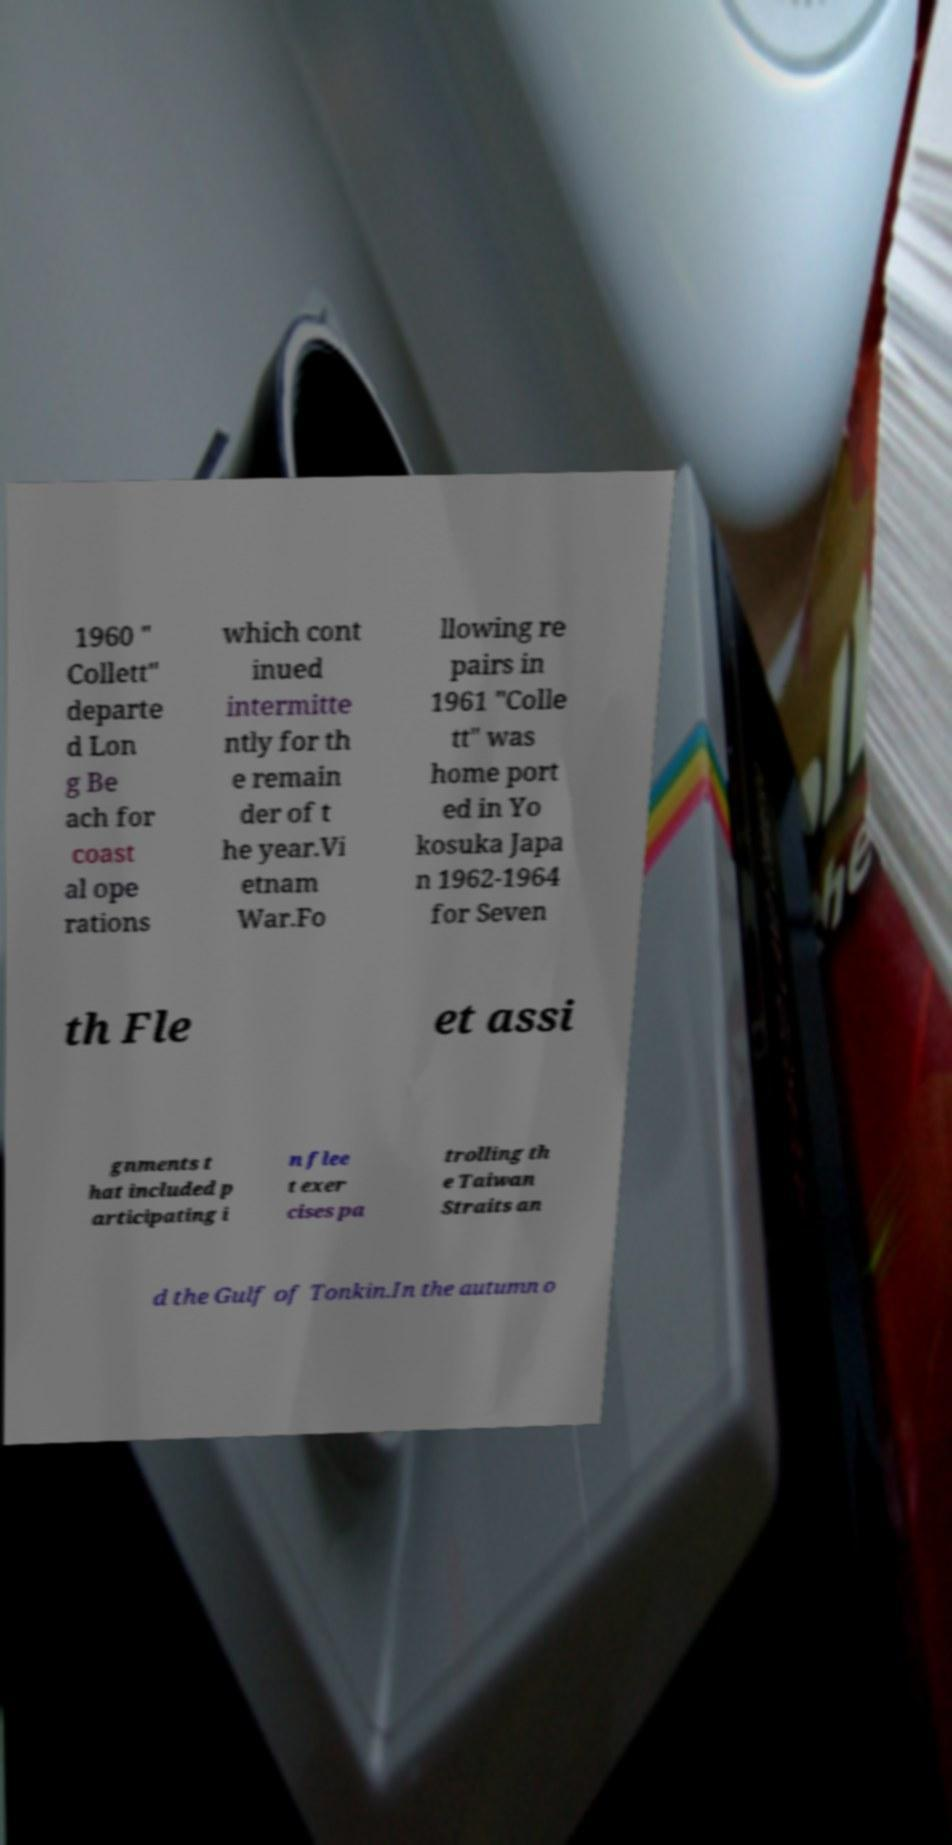Can you accurately transcribe the text from the provided image for me? 1960 " Collett" departe d Lon g Be ach for coast al ope rations which cont inued intermitte ntly for th e remain der of t he year.Vi etnam War.Fo llowing re pairs in 1961 "Colle tt" was home port ed in Yo kosuka Japa n 1962-1964 for Seven th Fle et assi gnments t hat included p articipating i n flee t exer cises pa trolling th e Taiwan Straits an d the Gulf of Tonkin.In the autumn o 